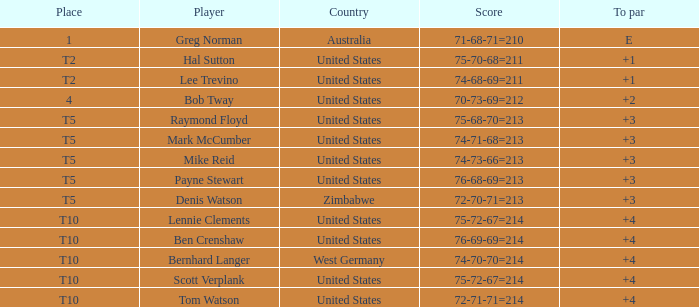Who is the competitor from the united states with a 75-70-68=211 score? Hal Sutton. 